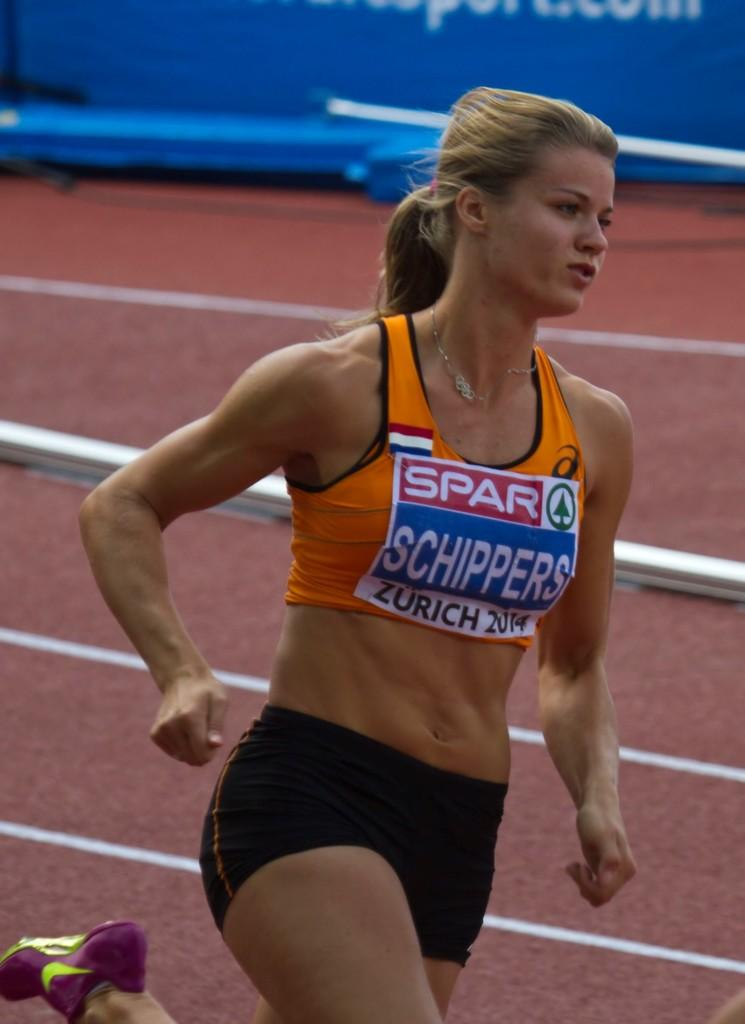<image>
Relay a brief, clear account of the picture shown. The city of Zurich is visible on an athlete's ID label. 